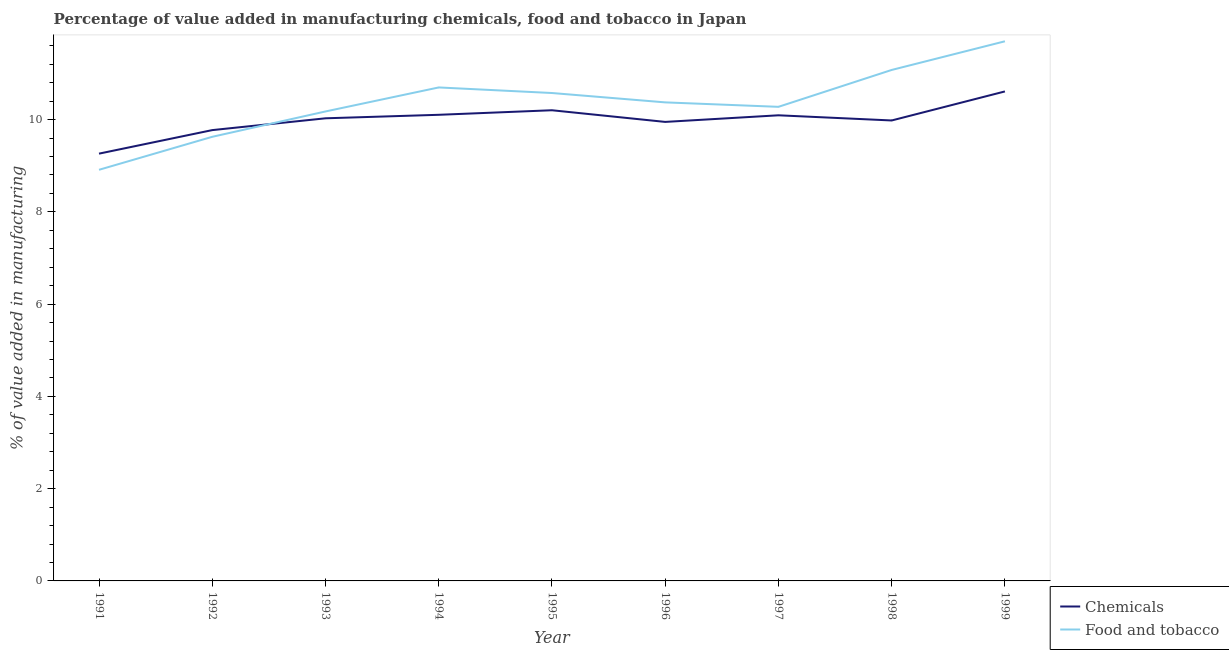Is the number of lines equal to the number of legend labels?
Offer a terse response. Yes. What is the value added by manufacturing food and tobacco in 1995?
Your answer should be compact. 10.58. Across all years, what is the maximum value added by  manufacturing chemicals?
Offer a terse response. 10.61. Across all years, what is the minimum value added by  manufacturing chemicals?
Offer a very short reply. 9.26. In which year was the value added by manufacturing food and tobacco maximum?
Offer a terse response. 1999. What is the total value added by manufacturing food and tobacco in the graph?
Make the answer very short. 93.42. What is the difference between the value added by manufacturing food and tobacco in 1992 and that in 1998?
Your response must be concise. -1.45. What is the difference between the value added by  manufacturing chemicals in 1991 and the value added by manufacturing food and tobacco in 1993?
Give a very brief answer. -0.91. What is the average value added by  manufacturing chemicals per year?
Your response must be concise. 10. In the year 1993, what is the difference between the value added by manufacturing food and tobacco and value added by  manufacturing chemicals?
Offer a very short reply. 0.15. What is the ratio of the value added by manufacturing food and tobacco in 1998 to that in 1999?
Give a very brief answer. 0.95. Is the difference between the value added by manufacturing food and tobacco in 1991 and 1997 greater than the difference between the value added by  manufacturing chemicals in 1991 and 1997?
Your response must be concise. No. What is the difference between the highest and the second highest value added by  manufacturing chemicals?
Your answer should be compact. 0.41. What is the difference between the highest and the lowest value added by manufacturing food and tobacco?
Offer a terse response. 2.79. In how many years, is the value added by manufacturing food and tobacco greater than the average value added by manufacturing food and tobacco taken over all years?
Your answer should be compact. 4. Does the value added by manufacturing food and tobacco monotonically increase over the years?
Your answer should be very brief. No. Is the value added by manufacturing food and tobacco strictly greater than the value added by  manufacturing chemicals over the years?
Make the answer very short. No. How many years are there in the graph?
Make the answer very short. 9. What is the difference between two consecutive major ticks on the Y-axis?
Provide a short and direct response. 2. Does the graph contain any zero values?
Your answer should be very brief. No. Does the graph contain grids?
Provide a succinct answer. No. Where does the legend appear in the graph?
Offer a very short reply. Bottom right. How are the legend labels stacked?
Provide a succinct answer. Vertical. What is the title of the graph?
Your response must be concise. Percentage of value added in manufacturing chemicals, food and tobacco in Japan. Does "Female population" appear as one of the legend labels in the graph?
Offer a terse response. No. What is the label or title of the Y-axis?
Your response must be concise. % of value added in manufacturing. What is the % of value added in manufacturing in Chemicals in 1991?
Provide a succinct answer. 9.26. What is the % of value added in manufacturing of Food and tobacco in 1991?
Provide a succinct answer. 8.91. What is the % of value added in manufacturing of Chemicals in 1992?
Make the answer very short. 9.77. What is the % of value added in manufacturing in Food and tobacco in 1992?
Your answer should be very brief. 9.63. What is the % of value added in manufacturing in Chemicals in 1993?
Your answer should be very brief. 10.03. What is the % of value added in manufacturing in Food and tobacco in 1993?
Give a very brief answer. 10.18. What is the % of value added in manufacturing of Chemicals in 1994?
Offer a terse response. 10.1. What is the % of value added in manufacturing of Food and tobacco in 1994?
Your response must be concise. 10.7. What is the % of value added in manufacturing in Chemicals in 1995?
Give a very brief answer. 10.2. What is the % of value added in manufacturing in Food and tobacco in 1995?
Keep it short and to the point. 10.58. What is the % of value added in manufacturing in Chemicals in 1996?
Offer a very short reply. 9.95. What is the % of value added in manufacturing of Food and tobacco in 1996?
Your response must be concise. 10.37. What is the % of value added in manufacturing in Chemicals in 1997?
Provide a short and direct response. 10.09. What is the % of value added in manufacturing of Food and tobacco in 1997?
Your response must be concise. 10.28. What is the % of value added in manufacturing in Chemicals in 1998?
Your answer should be very brief. 9.98. What is the % of value added in manufacturing of Food and tobacco in 1998?
Offer a terse response. 11.08. What is the % of value added in manufacturing of Chemicals in 1999?
Provide a succinct answer. 10.61. What is the % of value added in manufacturing of Food and tobacco in 1999?
Your answer should be very brief. 11.7. Across all years, what is the maximum % of value added in manufacturing of Chemicals?
Give a very brief answer. 10.61. Across all years, what is the maximum % of value added in manufacturing of Food and tobacco?
Give a very brief answer. 11.7. Across all years, what is the minimum % of value added in manufacturing of Chemicals?
Offer a very short reply. 9.26. Across all years, what is the minimum % of value added in manufacturing of Food and tobacco?
Ensure brevity in your answer.  8.91. What is the total % of value added in manufacturing of Chemicals in the graph?
Your answer should be very brief. 90.01. What is the total % of value added in manufacturing of Food and tobacco in the graph?
Your answer should be compact. 93.42. What is the difference between the % of value added in manufacturing in Chemicals in 1991 and that in 1992?
Your answer should be compact. -0.51. What is the difference between the % of value added in manufacturing of Food and tobacco in 1991 and that in 1992?
Keep it short and to the point. -0.72. What is the difference between the % of value added in manufacturing of Chemicals in 1991 and that in 1993?
Your response must be concise. -0.77. What is the difference between the % of value added in manufacturing of Food and tobacco in 1991 and that in 1993?
Make the answer very short. -1.26. What is the difference between the % of value added in manufacturing of Chemicals in 1991 and that in 1994?
Your response must be concise. -0.84. What is the difference between the % of value added in manufacturing of Food and tobacco in 1991 and that in 1994?
Provide a short and direct response. -1.79. What is the difference between the % of value added in manufacturing of Chemicals in 1991 and that in 1995?
Your response must be concise. -0.94. What is the difference between the % of value added in manufacturing of Food and tobacco in 1991 and that in 1995?
Offer a terse response. -1.66. What is the difference between the % of value added in manufacturing in Chemicals in 1991 and that in 1996?
Give a very brief answer. -0.69. What is the difference between the % of value added in manufacturing of Food and tobacco in 1991 and that in 1996?
Your answer should be compact. -1.46. What is the difference between the % of value added in manufacturing in Chemicals in 1991 and that in 1997?
Your response must be concise. -0.83. What is the difference between the % of value added in manufacturing of Food and tobacco in 1991 and that in 1997?
Give a very brief answer. -1.36. What is the difference between the % of value added in manufacturing in Chemicals in 1991 and that in 1998?
Provide a succinct answer. -0.72. What is the difference between the % of value added in manufacturing in Food and tobacco in 1991 and that in 1998?
Keep it short and to the point. -2.16. What is the difference between the % of value added in manufacturing of Chemicals in 1991 and that in 1999?
Your answer should be compact. -1.35. What is the difference between the % of value added in manufacturing of Food and tobacco in 1991 and that in 1999?
Your answer should be very brief. -2.79. What is the difference between the % of value added in manufacturing of Chemicals in 1992 and that in 1993?
Your answer should be compact. -0.26. What is the difference between the % of value added in manufacturing of Food and tobacco in 1992 and that in 1993?
Make the answer very short. -0.55. What is the difference between the % of value added in manufacturing of Chemicals in 1992 and that in 1994?
Offer a terse response. -0.33. What is the difference between the % of value added in manufacturing in Food and tobacco in 1992 and that in 1994?
Offer a very short reply. -1.07. What is the difference between the % of value added in manufacturing in Chemicals in 1992 and that in 1995?
Provide a short and direct response. -0.43. What is the difference between the % of value added in manufacturing of Food and tobacco in 1992 and that in 1995?
Make the answer very short. -0.95. What is the difference between the % of value added in manufacturing of Chemicals in 1992 and that in 1996?
Your response must be concise. -0.18. What is the difference between the % of value added in manufacturing of Food and tobacco in 1992 and that in 1996?
Your answer should be compact. -0.75. What is the difference between the % of value added in manufacturing of Chemicals in 1992 and that in 1997?
Provide a short and direct response. -0.32. What is the difference between the % of value added in manufacturing of Food and tobacco in 1992 and that in 1997?
Offer a terse response. -0.65. What is the difference between the % of value added in manufacturing in Chemicals in 1992 and that in 1998?
Give a very brief answer. -0.21. What is the difference between the % of value added in manufacturing in Food and tobacco in 1992 and that in 1998?
Provide a succinct answer. -1.45. What is the difference between the % of value added in manufacturing in Chemicals in 1992 and that in 1999?
Your answer should be very brief. -0.84. What is the difference between the % of value added in manufacturing of Food and tobacco in 1992 and that in 1999?
Ensure brevity in your answer.  -2.07. What is the difference between the % of value added in manufacturing in Chemicals in 1993 and that in 1994?
Offer a terse response. -0.08. What is the difference between the % of value added in manufacturing of Food and tobacco in 1993 and that in 1994?
Ensure brevity in your answer.  -0.52. What is the difference between the % of value added in manufacturing in Chemicals in 1993 and that in 1995?
Your answer should be very brief. -0.17. What is the difference between the % of value added in manufacturing in Food and tobacco in 1993 and that in 1995?
Make the answer very short. -0.4. What is the difference between the % of value added in manufacturing in Chemicals in 1993 and that in 1996?
Give a very brief answer. 0.08. What is the difference between the % of value added in manufacturing in Food and tobacco in 1993 and that in 1996?
Give a very brief answer. -0.2. What is the difference between the % of value added in manufacturing of Chemicals in 1993 and that in 1997?
Provide a short and direct response. -0.07. What is the difference between the % of value added in manufacturing in Food and tobacco in 1993 and that in 1997?
Offer a very short reply. -0.1. What is the difference between the % of value added in manufacturing of Chemicals in 1993 and that in 1998?
Provide a short and direct response. 0.05. What is the difference between the % of value added in manufacturing in Food and tobacco in 1993 and that in 1998?
Ensure brevity in your answer.  -0.9. What is the difference between the % of value added in manufacturing in Chemicals in 1993 and that in 1999?
Offer a terse response. -0.58. What is the difference between the % of value added in manufacturing in Food and tobacco in 1993 and that in 1999?
Your response must be concise. -1.52. What is the difference between the % of value added in manufacturing in Chemicals in 1994 and that in 1995?
Your answer should be compact. -0.1. What is the difference between the % of value added in manufacturing of Food and tobacco in 1994 and that in 1995?
Offer a very short reply. 0.12. What is the difference between the % of value added in manufacturing of Chemicals in 1994 and that in 1996?
Your answer should be very brief. 0.15. What is the difference between the % of value added in manufacturing in Food and tobacco in 1994 and that in 1996?
Ensure brevity in your answer.  0.32. What is the difference between the % of value added in manufacturing in Chemicals in 1994 and that in 1997?
Ensure brevity in your answer.  0.01. What is the difference between the % of value added in manufacturing of Food and tobacco in 1994 and that in 1997?
Ensure brevity in your answer.  0.42. What is the difference between the % of value added in manufacturing in Chemicals in 1994 and that in 1998?
Your answer should be compact. 0.12. What is the difference between the % of value added in manufacturing in Food and tobacco in 1994 and that in 1998?
Your response must be concise. -0.38. What is the difference between the % of value added in manufacturing in Chemicals in 1994 and that in 1999?
Provide a succinct answer. -0.51. What is the difference between the % of value added in manufacturing of Food and tobacco in 1994 and that in 1999?
Provide a short and direct response. -1. What is the difference between the % of value added in manufacturing in Chemicals in 1995 and that in 1996?
Your response must be concise. 0.25. What is the difference between the % of value added in manufacturing of Food and tobacco in 1995 and that in 1996?
Your answer should be very brief. 0.2. What is the difference between the % of value added in manufacturing of Chemicals in 1995 and that in 1997?
Your answer should be very brief. 0.11. What is the difference between the % of value added in manufacturing in Food and tobacco in 1995 and that in 1997?
Keep it short and to the point. 0.3. What is the difference between the % of value added in manufacturing of Chemicals in 1995 and that in 1998?
Offer a very short reply. 0.22. What is the difference between the % of value added in manufacturing of Food and tobacco in 1995 and that in 1998?
Ensure brevity in your answer.  -0.5. What is the difference between the % of value added in manufacturing of Chemicals in 1995 and that in 1999?
Give a very brief answer. -0.41. What is the difference between the % of value added in manufacturing in Food and tobacco in 1995 and that in 1999?
Provide a short and direct response. -1.12. What is the difference between the % of value added in manufacturing in Chemicals in 1996 and that in 1997?
Your answer should be compact. -0.14. What is the difference between the % of value added in manufacturing of Food and tobacco in 1996 and that in 1997?
Ensure brevity in your answer.  0.1. What is the difference between the % of value added in manufacturing in Chemicals in 1996 and that in 1998?
Offer a terse response. -0.03. What is the difference between the % of value added in manufacturing of Food and tobacco in 1996 and that in 1998?
Provide a short and direct response. -0.7. What is the difference between the % of value added in manufacturing in Chemicals in 1996 and that in 1999?
Offer a very short reply. -0.66. What is the difference between the % of value added in manufacturing in Food and tobacco in 1996 and that in 1999?
Offer a terse response. -1.32. What is the difference between the % of value added in manufacturing in Chemicals in 1997 and that in 1998?
Provide a short and direct response. 0.11. What is the difference between the % of value added in manufacturing of Food and tobacco in 1997 and that in 1998?
Your answer should be compact. -0.8. What is the difference between the % of value added in manufacturing of Chemicals in 1997 and that in 1999?
Your answer should be very brief. -0.52. What is the difference between the % of value added in manufacturing in Food and tobacco in 1997 and that in 1999?
Give a very brief answer. -1.42. What is the difference between the % of value added in manufacturing of Chemicals in 1998 and that in 1999?
Give a very brief answer. -0.63. What is the difference between the % of value added in manufacturing in Food and tobacco in 1998 and that in 1999?
Ensure brevity in your answer.  -0.62. What is the difference between the % of value added in manufacturing of Chemicals in 1991 and the % of value added in manufacturing of Food and tobacco in 1992?
Ensure brevity in your answer.  -0.37. What is the difference between the % of value added in manufacturing of Chemicals in 1991 and the % of value added in manufacturing of Food and tobacco in 1993?
Give a very brief answer. -0.91. What is the difference between the % of value added in manufacturing in Chemicals in 1991 and the % of value added in manufacturing in Food and tobacco in 1994?
Offer a terse response. -1.44. What is the difference between the % of value added in manufacturing of Chemicals in 1991 and the % of value added in manufacturing of Food and tobacco in 1995?
Give a very brief answer. -1.31. What is the difference between the % of value added in manufacturing of Chemicals in 1991 and the % of value added in manufacturing of Food and tobacco in 1996?
Your answer should be compact. -1.11. What is the difference between the % of value added in manufacturing in Chemicals in 1991 and the % of value added in manufacturing in Food and tobacco in 1997?
Make the answer very short. -1.01. What is the difference between the % of value added in manufacturing in Chemicals in 1991 and the % of value added in manufacturing in Food and tobacco in 1998?
Ensure brevity in your answer.  -1.81. What is the difference between the % of value added in manufacturing of Chemicals in 1991 and the % of value added in manufacturing of Food and tobacco in 1999?
Your answer should be compact. -2.44. What is the difference between the % of value added in manufacturing of Chemicals in 1992 and the % of value added in manufacturing of Food and tobacco in 1993?
Give a very brief answer. -0.4. What is the difference between the % of value added in manufacturing in Chemicals in 1992 and the % of value added in manufacturing in Food and tobacco in 1994?
Give a very brief answer. -0.92. What is the difference between the % of value added in manufacturing of Chemicals in 1992 and the % of value added in manufacturing of Food and tobacco in 1995?
Your answer should be very brief. -0.8. What is the difference between the % of value added in manufacturing of Chemicals in 1992 and the % of value added in manufacturing of Food and tobacco in 1996?
Offer a very short reply. -0.6. What is the difference between the % of value added in manufacturing in Chemicals in 1992 and the % of value added in manufacturing in Food and tobacco in 1997?
Provide a short and direct response. -0.5. What is the difference between the % of value added in manufacturing in Chemicals in 1992 and the % of value added in manufacturing in Food and tobacco in 1998?
Offer a very short reply. -1.3. What is the difference between the % of value added in manufacturing in Chemicals in 1992 and the % of value added in manufacturing in Food and tobacco in 1999?
Make the answer very short. -1.93. What is the difference between the % of value added in manufacturing of Chemicals in 1993 and the % of value added in manufacturing of Food and tobacco in 1994?
Your answer should be very brief. -0.67. What is the difference between the % of value added in manufacturing in Chemicals in 1993 and the % of value added in manufacturing in Food and tobacco in 1995?
Your response must be concise. -0.55. What is the difference between the % of value added in manufacturing of Chemicals in 1993 and the % of value added in manufacturing of Food and tobacco in 1996?
Provide a succinct answer. -0.35. What is the difference between the % of value added in manufacturing of Chemicals in 1993 and the % of value added in manufacturing of Food and tobacco in 1997?
Offer a very short reply. -0.25. What is the difference between the % of value added in manufacturing in Chemicals in 1993 and the % of value added in manufacturing in Food and tobacco in 1998?
Give a very brief answer. -1.05. What is the difference between the % of value added in manufacturing of Chemicals in 1993 and the % of value added in manufacturing of Food and tobacco in 1999?
Make the answer very short. -1.67. What is the difference between the % of value added in manufacturing in Chemicals in 1994 and the % of value added in manufacturing in Food and tobacco in 1995?
Keep it short and to the point. -0.47. What is the difference between the % of value added in manufacturing in Chemicals in 1994 and the % of value added in manufacturing in Food and tobacco in 1996?
Your response must be concise. -0.27. What is the difference between the % of value added in manufacturing of Chemicals in 1994 and the % of value added in manufacturing of Food and tobacco in 1997?
Your answer should be compact. -0.17. What is the difference between the % of value added in manufacturing in Chemicals in 1994 and the % of value added in manufacturing in Food and tobacco in 1998?
Give a very brief answer. -0.97. What is the difference between the % of value added in manufacturing of Chemicals in 1994 and the % of value added in manufacturing of Food and tobacco in 1999?
Make the answer very short. -1.59. What is the difference between the % of value added in manufacturing of Chemicals in 1995 and the % of value added in manufacturing of Food and tobacco in 1996?
Provide a short and direct response. -0.17. What is the difference between the % of value added in manufacturing in Chemicals in 1995 and the % of value added in manufacturing in Food and tobacco in 1997?
Ensure brevity in your answer.  -0.07. What is the difference between the % of value added in manufacturing of Chemicals in 1995 and the % of value added in manufacturing of Food and tobacco in 1998?
Give a very brief answer. -0.87. What is the difference between the % of value added in manufacturing in Chemicals in 1995 and the % of value added in manufacturing in Food and tobacco in 1999?
Provide a short and direct response. -1.49. What is the difference between the % of value added in manufacturing of Chemicals in 1996 and the % of value added in manufacturing of Food and tobacco in 1997?
Provide a short and direct response. -0.33. What is the difference between the % of value added in manufacturing in Chemicals in 1996 and the % of value added in manufacturing in Food and tobacco in 1998?
Keep it short and to the point. -1.13. What is the difference between the % of value added in manufacturing in Chemicals in 1996 and the % of value added in manufacturing in Food and tobacco in 1999?
Your answer should be very brief. -1.75. What is the difference between the % of value added in manufacturing of Chemicals in 1997 and the % of value added in manufacturing of Food and tobacco in 1998?
Your answer should be very brief. -0.98. What is the difference between the % of value added in manufacturing of Chemicals in 1997 and the % of value added in manufacturing of Food and tobacco in 1999?
Give a very brief answer. -1.6. What is the difference between the % of value added in manufacturing of Chemicals in 1998 and the % of value added in manufacturing of Food and tobacco in 1999?
Keep it short and to the point. -1.72. What is the average % of value added in manufacturing of Chemicals per year?
Your answer should be very brief. 10. What is the average % of value added in manufacturing of Food and tobacco per year?
Make the answer very short. 10.38. In the year 1991, what is the difference between the % of value added in manufacturing in Chemicals and % of value added in manufacturing in Food and tobacco?
Your response must be concise. 0.35. In the year 1992, what is the difference between the % of value added in manufacturing of Chemicals and % of value added in manufacturing of Food and tobacco?
Offer a terse response. 0.14. In the year 1993, what is the difference between the % of value added in manufacturing in Chemicals and % of value added in manufacturing in Food and tobacco?
Offer a terse response. -0.15. In the year 1994, what is the difference between the % of value added in manufacturing in Chemicals and % of value added in manufacturing in Food and tobacco?
Offer a very short reply. -0.59. In the year 1995, what is the difference between the % of value added in manufacturing in Chemicals and % of value added in manufacturing in Food and tobacco?
Offer a terse response. -0.37. In the year 1996, what is the difference between the % of value added in manufacturing in Chemicals and % of value added in manufacturing in Food and tobacco?
Your response must be concise. -0.42. In the year 1997, what is the difference between the % of value added in manufacturing of Chemicals and % of value added in manufacturing of Food and tobacco?
Offer a terse response. -0.18. In the year 1998, what is the difference between the % of value added in manufacturing of Chemicals and % of value added in manufacturing of Food and tobacco?
Ensure brevity in your answer.  -1.09. In the year 1999, what is the difference between the % of value added in manufacturing of Chemicals and % of value added in manufacturing of Food and tobacco?
Ensure brevity in your answer.  -1.09. What is the ratio of the % of value added in manufacturing of Chemicals in 1991 to that in 1992?
Keep it short and to the point. 0.95. What is the ratio of the % of value added in manufacturing of Food and tobacco in 1991 to that in 1992?
Offer a very short reply. 0.93. What is the ratio of the % of value added in manufacturing of Chemicals in 1991 to that in 1993?
Ensure brevity in your answer.  0.92. What is the ratio of the % of value added in manufacturing of Food and tobacco in 1991 to that in 1993?
Offer a very short reply. 0.88. What is the ratio of the % of value added in manufacturing of Chemicals in 1991 to that in 1994?
Keep it short and to the point. 0.92. What is the ratio of the % of value added in manufacturing in Food and tobacco in 1991 to that in 1994?
Provide a succinct answer. 0.83. What is the ratio of the % of value added in manufacturing of Chemicals in 1991 to that in 1995?
Provide a short and direct response. 0.91. What is the ratio of the % of value added in manufacturing in Food and tobacco in 1991 to that in 1995?
Provide a succinct answer. 0.84. What is the ratio of the % of value added in manufacturing of Chemicals in 1991 to that in 1996?
Give a very brief answer. 0.93. What is the ratio of the % of value added in manufacturing of Food and tobacco in 1991 to that in 1996?
Your response must be concise. 0.86. What is the ratio of the % of value added in manufacturing of Chemicals in 1991 to that in 1997?
Ensure brevity in your answer.  0.92. What is the ratio of the % of value added in manufacturing of Food and tobacco in 1991 to that in 1997?
Ensure brevity in your answer.  0.87. What is the ratio of the % of value added in manufacturing in Chemicals in 1991 to that in 1998?
Your answer should be very brief. 0.93. What is the ratio of the % of value added in manufacturing of Food and tobacco in 1991 to that in 1998?
Offer a terse response. 0.8. What is the ratio of the % of value added in manufacturing of Chemicals in 1991 to that in 1999?
Provide a succinct answer. 0.87. What is the ratio of the % of value added in manufacturing in Food and tobacco in 1991 to that in 1999?
Give a very brief answer. 0.76. What is the ratio of the % of value added in manufacturing of Chemicals in 1992 to that in 1993?
Offer a terse response. 0.97. What is the ratio of the % of value added in manufacturing in Food and tobacco in 1992 to that in 1993?
Offer a terse response. 0.95. What is the ratio of the % of value added in manufacturing of Chemicals in 1992 to that in 1994?
Your response must be concise. 0.97. What is the ratio of the % of value added in manufacturing in Food and tobacco in 1992 to that in 1994?
Ensure brevity in your answer.  0.9. What is the ratio of the % of value added in manufacturing of Chemicals in 1992 to that in 1995?
Provide a succinct answer. 0.96. What is the ratio of the % of value added in manufacturing in Food and tobacco in 1992 to that in 1995?
Your answer should be compact. 0.91. What is the ratio of the % of value added in manufacturing of Chemicals in 1992 to that in 1996?
Offer a very short reply. 0.98. What is the ratio of the % of value added in manufacturing of Food and tobacco in 1992 to that in 1996?
Offer a very short reply. 0.93. What is the ratio of the % of value added in manufacturing of Chemicals in 1992 to that in 1997?
Your response must be concise. 0.97. What is the ratio of the % of value added in manufacturing in Food and tobacco in 1992 to that in 1997?
Ensure brevity in your answer.  0.94. What is the ratio of the % of value added in manufacturing in Food and tobacco in 1992 to that in 1998?
Give a very brief answer. 0.87. What is the ratio of the % of value added in manufacturing in Chemicals in 1992 to that in 1999?
Offer a very short reply. 0.92. What is the ratio of the % of value added in manufacturing of Food and tobacco in 1992 to that in 1999?
Your response must be concise. 0.82. What is the ratio of the % of value added in manufacturing of Food and tobacco in 1993 to that in 1994?
Your response must be concise. 0.95. What is the ratio of the % of value added in manufacturing in Chemicals in 1993 to that in 1995?
Your response must be concise. 0.98. What is the ratio of the % of value added in manufacturing of Food and tobacco in 1993 to that in 1995?
Ensure brevity in your answer.  0.96. What is the ratio of the % of value added in manufacturing in Chemicals in 1993 to that in 1996?
Provide a succinct answer. 1.01. What is the ratio of the % of value added in manufacturing of Food and tobacco in 1993 to that in 1997?
Ensure brevity in your answer.  0.99. What is the ratio of the % of value added in manufacturing in Food and tobacco in 1993 to that in 1998?
Your answer should be compact. 0.92. What is the ratio of the % of value added in manufacturing in Chemicals in 1993 to that in 1999?
Your answer should be compact. 0.95. What is the ratio of the % of value added in manufacturing of Food and tobacco in 1993 to that in 1999?
Give a very brief answer. 0.87. What is the ratio of the % of value added in manufacturing of Chemicals in 1994 to that in 1995?
Give a very brief answer. 0.99. What is the ratio of the % of value added in manufacturing of Food and tobacco in 1994 to that in 1995?
Your response must be concise. 1.01. What is the ratio of the % of value added in manufacturing in Chemicals in 1994 to that in 1996?
Ensure brevity in your answer.  1.02. What is the ratio of the % of value added in manufacturing of Food and tobacco in 1994 to that in 1996?
Make the answer very short. 1.03. What is the ratio of the % of value added in manufacturing in Food and tobacco in 1994 to that in 1997?
Offer a very short reply. 1.04. What is the ratio of the % of value added in manufacturing of Chemicals in 1994 to that in 1998?
Make the answer very short. 1.01. What is the ratio of the % of value added in manufacturing of Food and tobacco in 1994 to that in 1998?
Make the answer very short. 0.97. What is the ratio of the % of value added in manufacturing of Chemicals in 1994 to that in 1999?
Your answer should be compact. 0.95. What is the ratio of the % of value added in manufacturing in Food and tobacco in 1994 to that in 1999?
Provide a short and direct response. 0.91. What is the ratio of the % of value added in manufacturing in Chemicals in 1995 to that in 1996?
Give a very brief answer. 1.03. What is the ratio of the % of value added in manufacturing of Food and tobacco in 1995 to that in 1996?
Ensure brevity in your answer.  1.02. What is the ratio of the % of value added in manufacturing in Chemicals in 1995 to that in 1997?
Provide a succinct answer. 1.01. What is the ratio of the % of value added in manufacturing of Food and tobacco in 1995 to that in 1997?
Your answer should be very brief. 1.03. What is the ratio of the % of value added in manufacturing in Chemicals in 1995 to that in 1998?
Ensure brevity in your answer.  1.02. What is the ratio of the % of value added in manufacturing of Food and tobacco in 1995 to that in 1998?
Keep it short and to the point. 0.95. What is the ratio of the % of value added in manufacturing of Chemicals in 1995 to that in 1999?
Your answer should be very brief. 0.96. What is the ratio of the % of value added in manufacturing of Food and tobacco in 1995 to that in 1999?
Give a very brief answer. 0.9. What is the ratio of the % of value added in manufacturing in Chemicals in 1996 to that in 1997?
Ensure brevity in your answer.  0.99. What is the ratio of the % of value added in manufacturing of Food and tobacco in 1996 to that in 1997?
Provide a succinct answer. 1.01. What is the ratio of the % of value added in manufacturing of Food and tobacco in 1996 to that in 1998?
Offer a terse response. 0.94. What is the ratio of the % of value added in manufacturing of Chemicals in 1996 to that in 1999?
Give a very brief answer. 0.94. What is the ratio of the % of value added in manufacturing in Food and tobacco in 1996 to that in 1999?
Your answer should be very brief. 0.89. What is the ratio of the % of value added in manufacturing in Chemicals in 1997 to that in 1998?
Offer a very short reply. 1.01. What is the ratio of the % of value added in manufacturing in Food and tobacco in 1997 to that in 1998?
Your answer should be compact. 0.93. What is the ratio of the % of value added in manufacturing in Chemicals in 1997 to that in 1999?
Your answer should be very brief. 0.95. What is the ratio of the % of value added in manufacturing of Food and tobacco in 1997 to that in 1999?
Ensure brevity in your answer.  0.88. What is the ratio of the % of value added in manufacturing of Chemicals in 1998 to that in 1999?
Your response must be concise. 0.94. What is the ratio of the % of value added in manufacturing of Food and tobacco in 1998 to that in 1999?
Your response must be concise. 0.95. What is the difference between the highest and the second highest % of value added in manufacturing in Chemicals?
Your answer should be compact. 0.41. What is the difference between the highest and the second highest % of value added in manufacturing in Food and tobacco?
Provide a succinct answer. 0.62. What is the difference between the highest and the lowest % of value added in manufacturing in Chemicals?
Provide a short and direct response. 1.35. What is the difference between the highest and the lowest % of value added in manufacturing in Food and tobacco?
Your answer should be very brief. 2.79. 